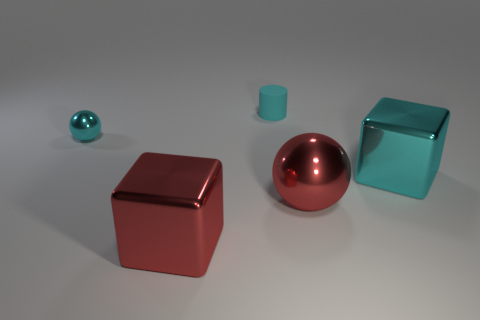Add 3 tiny yellow things. How many objects exist? 8 Subtract all cubes. How many objects are left? 3 Subtract 0 yellow cubes. How many objects are left? 5 Subtract all red metal cubes. Subtract all large red spheres. How many objects are left? 3 Add 3 cyan rubber things. How many cyan rubber things are left? 4 Add 4 small cyan metallic things. How many small cyan metallic things exist? 5 